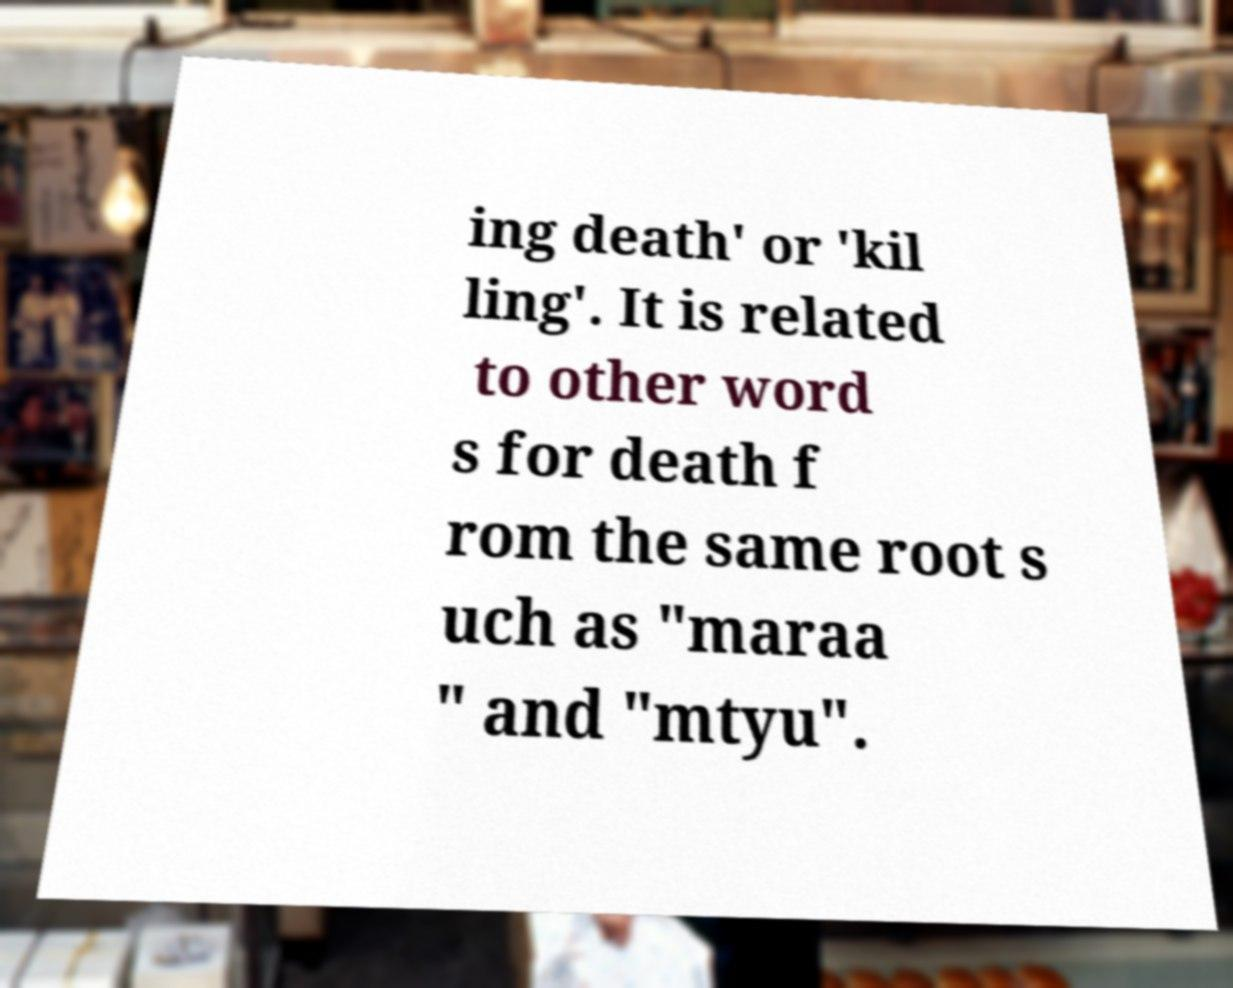Please identify and transcribe the text found in this image. ing death' or 'kil ling'. It is related to other word s for death f rom the same root s uch as "maraa " and "mtyu". 